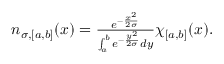<formula> <loc_0><loc_0><loc_500><loc_500>\begin{array} { r } { n _ { \sigma , [ a , b ] } ( x ) = \frac { e ^ { - \frac { x ^ { 2 } } { 2 \sigma } } } { \int _ { a } ^ { b } e ^ { - \frac { y ^ { 2 } } { 2 \sigma } } d y } \chi _ { [ a , b ] } ( x ) . } \end{array}</formula> 